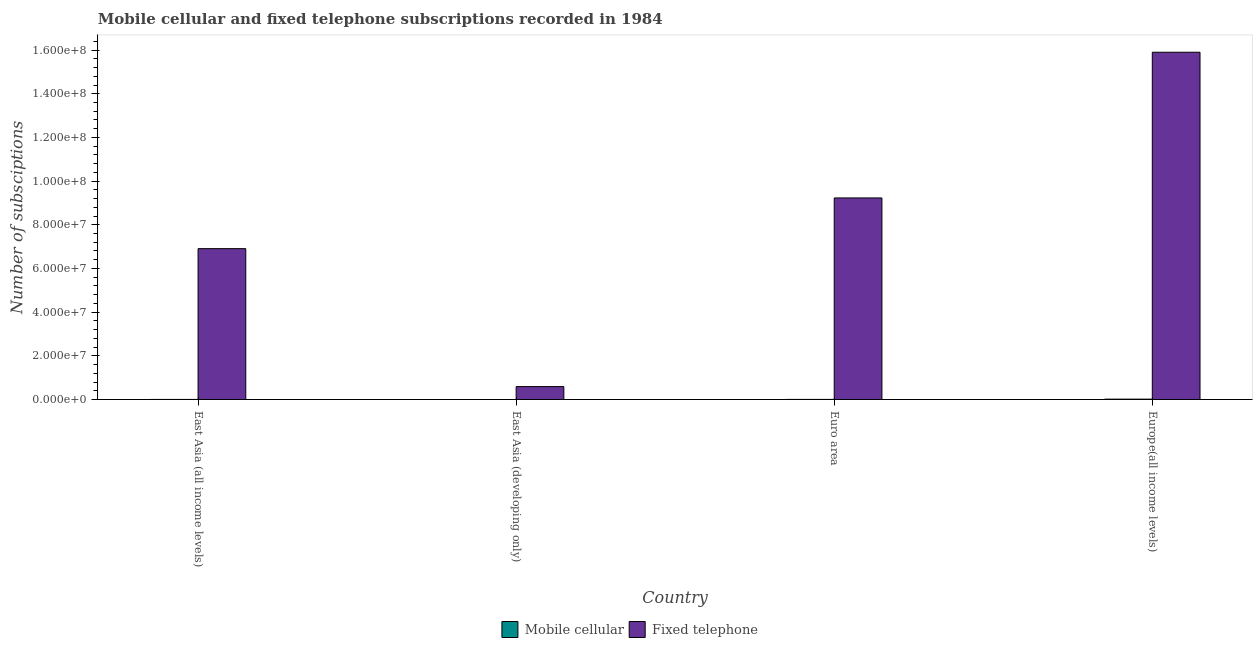How many different coloured bars are there?
Give a very brief answer. 2. Are the number of bars per tick equal to the number of legend labels?
Provide a succinct answer. Yes. How many bars are there on the 1st tick from the left?
Offer a terse response. 2. How many bars are there on the 2nd tick from the right?
Your answer should be compact. 2. What is the label of the 4th group of bars from the left?
Your response must be concise. Europe(all income levels). In how many cases, is the number of bars for a given country not equal to the number of legend labels?
Your response must be concise. 0. What is the number of fixed telephone subscriptions in Euro area?
Make the answer very short. 9.23e+07. Across all countries, what is the maximum number of fixed telephone subscriptions?
Make the answer very short. 1.59e+08. Across all countries, what is the minimum number of fixed telephone subscriptions?
Your answer should be very brief. 5.92e+06. In which country was the number of mobile cellular subscriptions maximum?
Your answer should be very brief. Europe(all income levels). In which country was the number of mobile cellular subscriptions minimum?
Your response must be concise. East Asia (developing only). What is the total number of mobile cellular subscriptions in the graph?
Offer a terse response. 2.76e+05. What is the difference between the number of mobile cellular subscriptions in East Asia (all income levels) and that in East Asia (developing only)?
Your answer should be very brief. 4.14e+04. What is the difference between the number of mobile cellular subscriptions in Euro area and the number of fixed telephone subscriptions in Europe(all income levels)?
Offer a terse response. -1.59e+08. What is the average number of mobile cellular subscriptions per country?
Offer a very short reply. 6.91e+04. What is the difference between the number of mobile cellular subscriptions and number of fixed telephone subscriptions in East Asia (all income levels)?
Provide a short and direct response. -6.90e+07. In how many countries, is the number of fixed telephone subscriptions greater than 72000000 ?
Provide a succinct answer. 2. What is the ratio of the number of mobile cellular subscriptions in East Asia (all income levels) to that in East Asia (developing only)?
Provide a short and direct response. 24.65. Is the difference between the number of fixed telephone subscriptions in East Asia (developing only) and Euro area greater than the difference between the number of mobile cellular subscriptions in East Asia (developing only) and Euro area?
Your answer should be very brief. No. What is the difference between the highest and the second highest number of mobile cellular subscriptions?
Provide a succinct answer. 1.28e+05. What is the difference between the highest and the lowest number of fixed telephone subscriptions?
Provide a short and direct response. 1.53e+08. In how many countries, is the number of mobile cellular subscriptions greater than the average number of mobile cellular subscriptions taken over all countries?
Offer a very short reply. 1. What does the 1st bar from the left in East Asia (all income levels) represents?
Your response must be concise. Mobile cellular. What does the 1st bar from the right in Euro area represents?
Offer a very short reply. Fixed telephone. How many bars are there?
Offer a terse response. 8. Are all the bars in the graph horizontal?
Provide a short and direct response. No. What is the difference between two consecutive major ticks on the Y-axis?
Offer a terse response. 2.00e+07. Does the graph contain any zero values?
Your answer should be compact. No. Does the graph contain grids?
Keep it short and to the point. No. What is the title of the graph?
Offer a very short reply. Mobile cellular and fixed telephone subscriptions recorded in 1984. Does "International Tourists" appear as one of the legend labels in the graph?
Your response must be concise. No. What is the label or title of the X-axis?
Offer a very short reply. Country. What is the label or title of the Y-axis?
Provide a short and direct response. Number of subsciptions. What is the Number of subsciptions in Mobile cellular in East Asia (all income levels)?
Keep it short and to the point. 4.31e+04. What is the Number of subsciptions in Fixed telephone in East Asia (all income levels)?
Make the answer very short. 6.91e+07. What is the Number of subsciptions in Mobile cellular in East Asia (developing only)?
Keep it short and to the point. 1750. What is the Number of subsciptions of Fixed telephone in East Asia (developing only)?
Provide a short and direct response. 5.92e+06. What is the Number of subsciptions of Mobile cellular in Euro area?
Give a very brief answer. 5.20e+04. What is the Number of subsciptions in Fixed telephone in Euro area?
Provide a succinct answer. 9.23e+07. What is the Number of subsciptions of Mobile cellular in Europe(all income levels)?
Give a very brief answer. 1.80e+05. What is the Number of subsciptions of Fixed telephone in Europe(all income levels)?
Your response must be concise. 1.59e+08. Across all countries, what is the maximum Number of subsciptions of Mobile cellular?
Provide a short and direct response. 1.80e+05. Across all countries, what is the maximum Number of subsciptions in Fixed telephone?
Provide a succinct answer. 1.59e+08. Across all countries, what is the minimum Number of subsciptions of Mobile cellular?
Provide a short and direct response. 1750. Across all countries, what is the minimum Number of subsciptions of Fixed telephone?
Your response must be concise. 5.92e+06. What is the total Number of subsciptions of Mobile cellular in the graph?
Ensure brevity in your answer.  2.76e+05. What is the total Number of subsciptions in Fixed telephone in the graph?
Offer a terse response. 3.26e+08. What is the difference between the Number of subsciptions of Mobile cellular in East Asia (all income levels) and that in East Asia (developing only)?
Offer a terse response. 4.14e+04. What is the difference between the Number of subsciptions of Fixed telephone in East Asia (all income levels) and that in East Asia (developing only)?
Your response must be concise. 6.32e+07. What is the difference between the Number of subsciptions of Mobile cellular in East Asia (all income levels) and that in Euro area?
Your answer should be very brief. -8868. What is the difference between the Number of subsciptions in Fixed telephone in East Asia (all income levels) and that in Euro area?
Your answer should be compact. -2.32e+07. What is the difference between the Number of subsciptions of Mobile cellular in East Asia (all income levels) and that in Europe(all income levels)?
Offer a terse response. -1.36e+05. What is the difference between the Number of subsciptions in Fixed telephone in East Asia (all income levels) and that in Europe(all income levels)?
Give a very brief answer. -8.99e+07. What is the difference between the Number of subsciptions in Mobile cellular in East Asia (developing only) and that in Euro area?
Your answer should be very brief. -5.03e+04. What is the difference between the Number of subsciptions in Fixed telephone in East Asia (developing only) and that in Euro area?
Offer a terse response. -8.64e+07. What is the difference between the Number of subsciptions of Mobile cellular in East Asia (developing only) and that in Europe(all income levels)?
Your answer should be very brief. -1.78e+05. What is the difference between the Number of subsciptions of Fixed telephone in East Asia (developing only) and that in Europe(all income levels)?
Provide a short and direct response. -1.53e+08. What is the difference between the Number of subsciptions of Mobile cellular in Euro area and that in Europe(all income levels)?
Your response must be concise. -1.28e+05. What is the difference between the Number of subsciptions in Fixed telephone in Euro area and that in Europe(all income levels)?
Give a very brief answer. -6.67e+07. What is the difference between the Number of subsciptions in Mobile cellular in East Asia (all income levels) and the Number of subsciptions in Fixed telephone in East Asia (developing only)?
Keep it short and to the point. -5.88e+06. What is the difference between the Number of subsciptions in Mobile cellular in East Asia (all income levels) and the Number of subsciptions in Fixed telephone in Euro area?
Keep it short and to the point. -9.22e+07. What is the difference between the Number of subsciptions in Mobile cellular in East Asia (all income levels) and the Number of subsciptions in Fixed telephone in Europe(all income levels)?
Keep it short and to the point. -1.59e+08. What is the difference between the Number of subsciptions of Mobile cellular in East Asia (developing only) and the Number of subsciptions of Fixed telephone in Euro area?
Provide a short and direct response. -9.23e+07. What is the difference between the Number of subsciptions of Mobile cellular in East Asia (developing only) and the Number of subsciptions of Fixed telephone in Europe(all income levels)?
Provide a succinct answer. -1.59e+08. What is the difference between the Number of subsciptions of Mobile cellular in Euro area and the Number of subsciptions of Fixed telephone in Europe(all income levels)?
Ensure brevity in your answer.  -1.59e+08. What is the average Number of subsciptions in Mobile cellular per country?
Your answer should be very brief. 6.91e+04. What is the average Number of subsciptions in Fixed telephone per country?
Ensure brevity in your answer.  8.16e+07. What is the difference between the Number of subsciptions of Mobile cellular and Number of subsciptions of Fixed telephone in East Asia (all income levels)?
Offer a terse response. -6.90e+07. What is the difference between the Number of subsciptions of Mobile cellular and Number of subsciptions of Fixed telephone in East Asia (developing only)?
Give a very brief answer. -5.92e+06. What is the difference between the Number of subsciptions of Mobile cellular and Number of subsciptions of Fixed telephone in Euro area?
Your response must be concise. -9.22e+07. What is the difference between the Number of subsciptions in Mobile cellular and Number of subsciptions in Fixed telephone in Europe(all income levels)?
Offer a very short reply. -1.59e+08. What is the ratio of the Number of subsciptions of Mobile cellular in East Asia (all income levels) to that in East Asia (developing only)?
Offer a terse response. 24.65. What is the ratio of the Number of subsciptions of Fixed telephone in East Asia (all income levels) to that in East Asia (developing only)?
Give a very brief answer. 11.66. What is the ratio of the Number of subsciptions of Mobile cellular in East Asia (all income levels) to that in Euro area?
Offer a very short reply. 0.83. What is the ratio of the Number of subsciptions of Fixed telephone in East Asia (all income levels) to that in Euro area?
Ensure brevity in your answer.  0.75. What is the ratio of the Number of subsciptions in Mobile cellular in East Asia (all income levels) to that in Europe(all income levels)?
Keep it short and to the point. 0.24. What is the ratio of the Number of subsciptions in Fixed telephone in East Asia (all income levels) to that in Europe(all income levels)?
Your answer should be compact. 0.43. What is the ratio of the Number of subsciptions in Mobile cellular in East Asia (developing only) to that in Euro area?
Give a very brief answer. 0.03. What is the ratio of the Number of subsciptions in Fixed telephone in East Asia (developing only) to that in Euro area?
Offer a terse response. 0.06. What is the ratio of the Number of subsciptions in Mobile cellular in East Asia (developing only) to that in Europe(all income levels)?
Make the answer very short. 0.01. What is the ratio of the Number of subsciptions of Fixed telephone in East Asia (developing only) to that in Europe(all income levels)?
Offer a very short reply. 0.04. What is the ratio of the Number of subsciptions in Mobile cellular in Euro area to that in Europe(all income levels)?
Your response must be concise. 0.29. What is the ratio of the Number of subsciptions in Fixed telephone in Euro area to that in Europe(all income levels)?
Your answer should be compact. 0.58. What is the difference between the highest and the second highest Number of subsciptions of Mobile cellular?
Offer a terse response. 1.28e+05. What is the difference between the highest and the second highest Number of subsciptions in Fixed telephone?
Your answer should be very brief. 6.67e+07. What is the difference between the highest and the lowest Number of subsciptions in Mobile cellular?
Offer a very short reply. 1.78e+05. What is the difference between the highest and the lowest Number of subsciptions in Fixed telephone?
Offer a very short reply. 1.53e+08. 